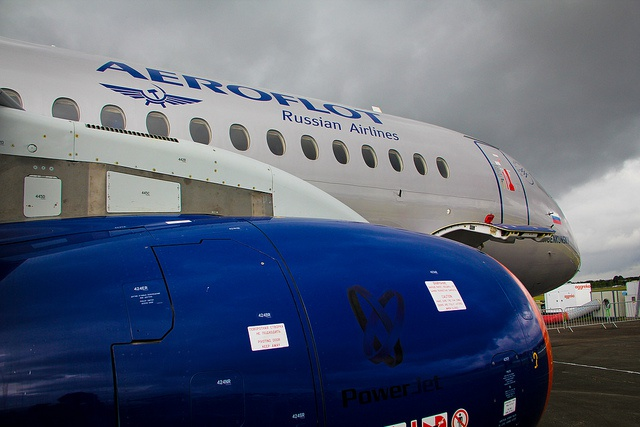Describe the objects in this image and their specific colors. I can see a airplane in gray, navy, darkgray, and black tones in this image. 